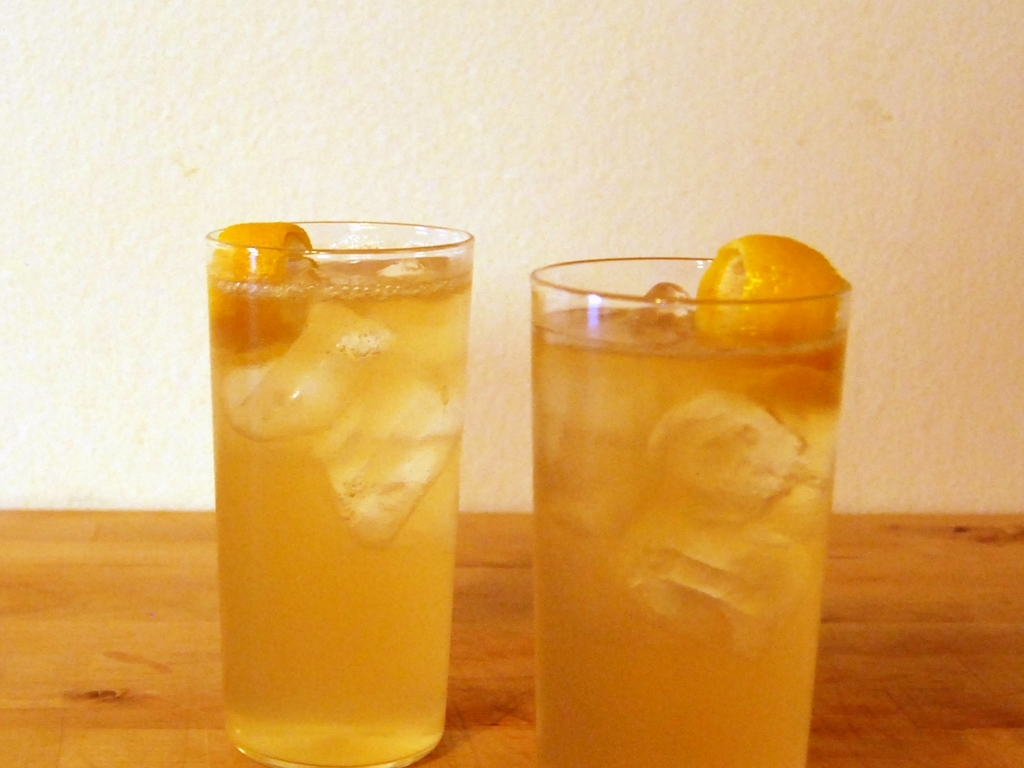Could you describe the atmosphere that these drinks help to create? The presence of these chilled glasses suggests a laid-back and convivial atmosphere. The chilled nature of the drinks implies a desire to beat the heat, indicating a warm, possibly outdoor setting where people gather to unwind and socialize. The overall simplicity of the presentation conveys a no-frills, focus-on-comfort setting where the goal is to enjoy good company and simple pleasures. 